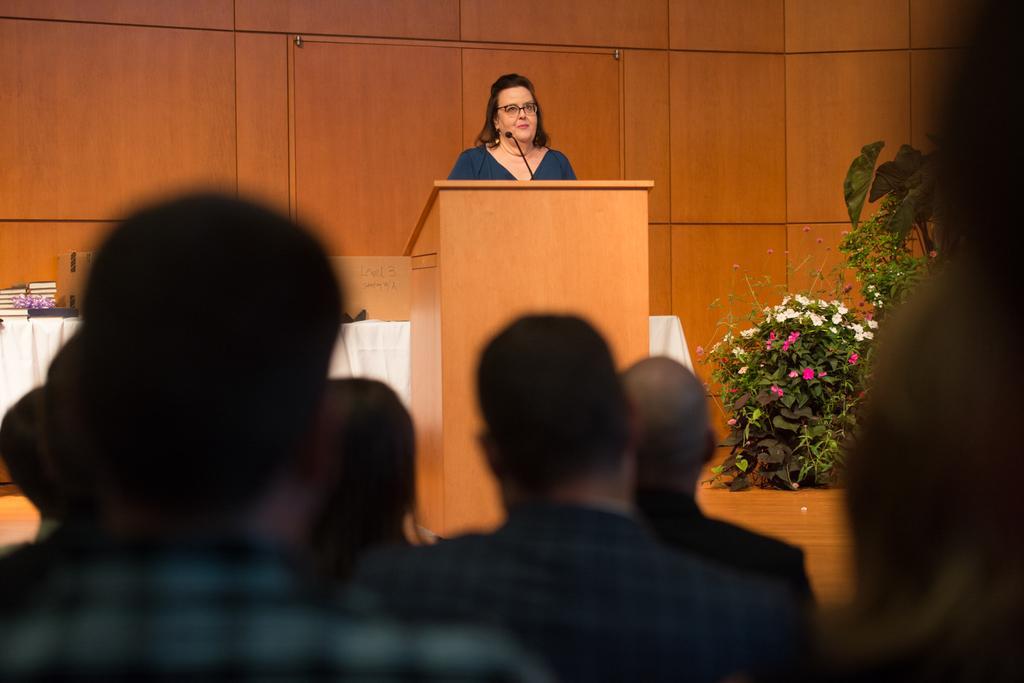Describe this image in one or two sentences. In this image I can see people sitting in the front. A person is standing at the back, there is a microphone and a speech desk in front of her. There are flower plants on the right and there is a white table behind her. There is a wooden background. 